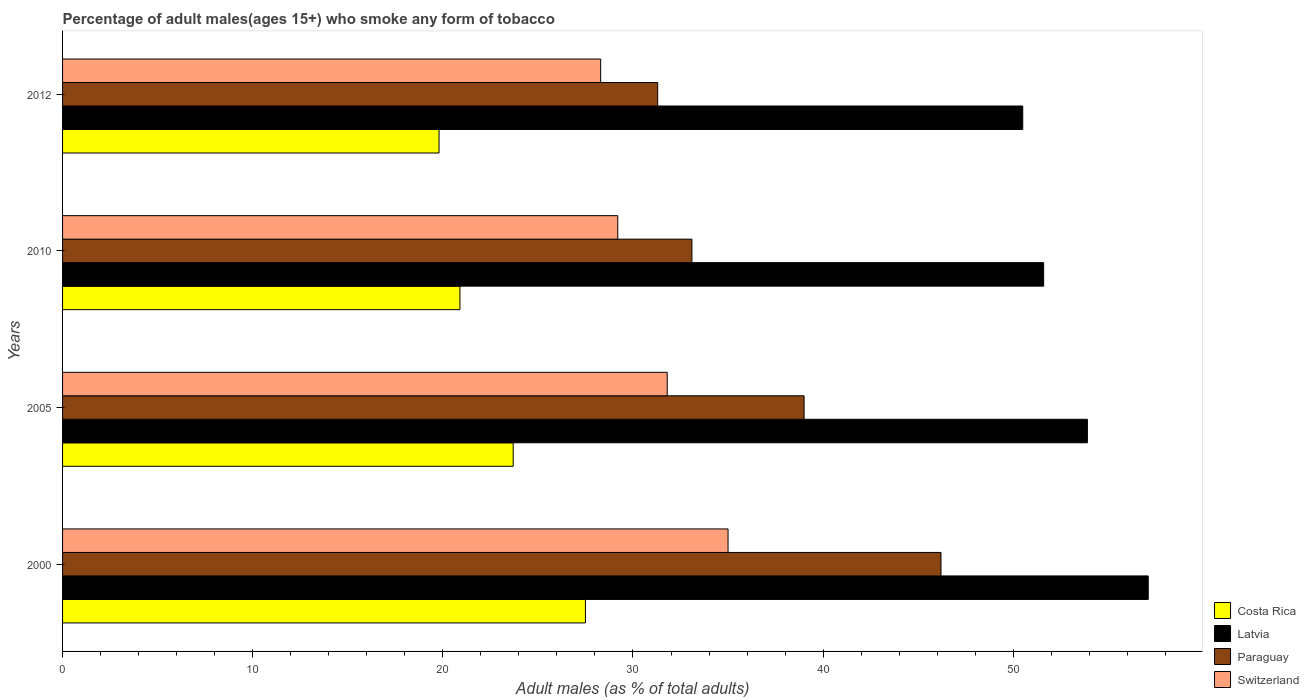Are the number of bars per tick equal to the number of legend labels?
Provide a short and direct response. Yes. How many bars are there on the 2nd tick from the bottom?
Offer a very short reply. 4. What is the percentage of adult males who smoke in Costa Rica in 2005?
Ensure brevity in your answer.  23.7. Across all years, what is the maximum percentage of adult males who smoke in Latvia?
Offer a terse response. 57.1. Across all years, what is the minimum percentage of adult males who smoke in Switzerland?
Offer a very short reply. 28.3. In which year was the percentage of adult males who smoke in Latvia minimum?
Offer a very short reply. 2012. What is the total percentage of adult males who smoke in Switzerland in the graph?
Keep it short and to the point. 124.3. What is the difference between the percentage of adult males who smoke in Switzerland in 2000 and that in 2012?
Offer a very short reply. 6.7. What is the average percentage of adult males who smoke in Costa Rica per year?
Your answer should be very brief. 22.97. In the year 2005, what is the difference between the percentage of adult males who smoke in Switzerland and percentage of adult males who smoke in Latvia?
Offer a terse response. -22.1. In how many years, is the percentage of adult males who smoke in Paraguay greater than 48 %?
Keep it short and to the point. 0. What is the ratio of the percentage of adult males who smoke in Latvia in 2000 to that in 2012?
Make the answer very short. 1.13. Is the difference between the percentage of adult males who smoke in Switzerland in 2000 and 2012 greater than the difference between the percentage of adult males who smoke in Latvia in 2000 and 2012?
Your answer should be compact. Yes. What is the difference between the highest and the second highest percentage of adult males who smoke in Paraguay?
Keep it short and to the point. 7.2. What is the difference between the highest and the lowest percentage of adult males who smoke in Switzerland?
Keep it short and to the point. 6.7. Is the sum of the percentage of adult males who smoke in Switzerland in 2010 and 2012 greater than the maximum percentage of adult males who smoke in Latvia across all years?
Offer a very short reply. Yes. Is it the case that in every year, the sum of the percentage of adult males who smoke in Costa Rica and percentage of adult males who smoke in Switzerland is greater than the sum of percentage of adult males who smoke in Paraguay and percentage of adult males who smoke in Latvia?
Provide a short and direct response. No. What does the 2nd bar from the bottom in 2000 represents?
Your answer should be compact. Latvia. Is it the case that in every year, the sum of the percentage of adult males who smoke in Switzerland and percentage of adult males who smoke in Costa Rica is greater than the percentage of adult males who smoke in Latvia?
Make the answer very short. No. How many bars are there?
Offer a very short reply. 16. Are all the bars in the graph horizontal?
Your answer should be compact. Yes. How many years are there in the graph?
Give a very brief answer. 4. What is the difference between two consecutive major ticks on the X-axis?
Offer a terse response. 10. Are the values on the major ticks of X-axis written in scientific E-notation?
Your response must be concise. No. Does the graph contain any zero values?
Your response must be concise. No. Does the graph contain grids?
Offer a very short reply. No. Where does the legend appear in the graph?
Keep it short and to the point. Bottom right. How many legend labels are there?
Provide a succinct answer. 4. What is the title of the graph?
Give a very brief answer. Percentage of adult males(ages 15+) who smoke any form of tobacco. What is the label or title of the X-axis?
Keep it short and to the point. Adult males (as % of total adults). What is the label or title of the Y-axis?
Give a very brief answer. Years. What is the Adult males (as % of total adults) in Costa Rica in 2000?
Your answer should be compact. 27.5. What is the Adult males (as % of total adults) of Latvia in 2000?
Provide a short and direct response. 57.1. What is the Adult males (as % of total adults) in Paraguay in 2000?
Your response must be concise. 46.2. What is the Adult males (as % of total adults) of Costa Rica in 2005?
Your response must be concise. 23.7. What is the Adult males (as % of total adults) of Latvia in 2005?
Give a very brief answer. 53.9. What is the Adult males (as % of total adults) in Switzerland in 2005?
Your answer should be very brief. 31.8. What is the Adult males (as % of total adults) in Costa Rica in 2010?
Keep it short and to the point. 20.9. What is the Adult males (as % of total adults) of Latvia in 2010?
Offer a terse response. 51.6. What is the Adult males (as % of total adults) of Paraguay in 2010?
Provide a succinct answer. 33.1. What is the Adult males (as % of total adults) of Switzerland in 2010?
Make the answer very short. 29.2. What is the Adult males (as % of total adults) of Costa Rica in 2012?
Ensure brevity in your answer.  19.8. What is the Adult males (as % of total adults) of Latvia in 2012?
Make the answer very short. 50.5. What is the Adult males (as % of total adults) of Paraguay in 2012?
Give a very brief answer. 31.3. What is the Adult males (as % of total adults) in Switzerland in 2012?
Your response must be concise. 28.3. Across all years, what is the maximum Adult males (as % of total adults) of Latvia?
Make the answer very short. 57.1. Across all years, what is the maximum Adult males (as % of total adults) in Paraguay?
Provide a short and direct response. 46.2. Across all years, what is the minimum Adult males (as % of total adults) of Costa Rica?
Make the answer very short. 19.8. Across all years, what is the minimum Adult males (as % of total adults) of Latvia?
Your answer should be compact. 50.5. Across all years, what is the minimum Adult males (as % of total adults) in Paraguay?
Ensure brevity in your answer.  31.3. Across all years, what is the minimum Adult males (as % of total adults) in Switzerland?
Your response must be concise. 28.3. What is the total Adult males (as % of total adults) of Costa Rica in the graph?
Your answer should be very brief. 91.9. What is the total Adult males (as % of total adults) in Latvia in the graph?
Provide a succinct answer. 213.1. What is the total Adult males (as % of total adults) of Paraguay in the graph?
Ensure brevity in your answer.  149.6. What is the total Adult males (as % of total adults) in Switzerland in the graph?
Your response must be concise. 124.3. What is the difference between the Adult males (as % of total adults) in Latvia in 2000 and that in 2005?
Your answer should be very brief. 3.2. What is the difference between the Adult males (as % of total adults) of Paraguay in 2000 and that in 2010?
Your answer should be very brief. 13.1. What is the difference between the Adult males (as % of total adults) in Switzerland in 2000 and that in 2010?
Your answer should be very brief. 5.8. What is the difference between the Adult males (as % of total adults) in Latvia in 2005 and that in 2010?
Your response must be concise. 2.3. What is the difference between the Adult males (as % of total adults) in Paraguay in 2005 and that in 2010?
Your response must be concise. 5.9. What is the difference between the Adult males (as % of total adults) of Latvia in 2005 and that in 2012?
Ensure brevity in your answer.  3.4. What is the difference between the Adult males (as % of total adults) in Paraguay in 2005 and that in 2012?
Ensure brevity in your answer.  7.7. What is the difference between the Adult males (as % of total adults) of Switzerland in 2005 and that in 2012?
Provide a succinct answer. 3.5. What is the difference between the Adult males (as % of total adults) of Latvia in 2010 and that in 2012?
Keep it short and to the point. 1.1. What is the difference between the Adult males (as % of total adults) of Paraguay in 2010 and that in 2012?
Make the answer very short. 1.8. What is the difference between the Adult males (as % of total adults) of Switzerland in 2010 and that in 2012?
Your response must be concise. 0.9. What is the difference between the Adult males (as % of total adults) of Costa Rica in 2000 and the Adult males (as % of total adults) of Latvia in 2005?
Keep it short and to the point. -26.4. What is the difference between the Adult males (as % of total adults) of Costa Rica in 2000 and the Adult males (as % of total adults) of Paraguay in 2005?
Make the answer very short. -11.5. What is the difference between the Adult males (as % of total adults) of Latvia in 2000 and the Adult males (as % of total adults) of Switzerland in 2005?
Make the answer very short. 25.3. What is the difference between the Adult males (as % of total adults) of Costa Rica in 2000 and the Adult males (as % of total adults) of Latvia in 2010?
Ensure brevity in your answer.  -24.1. What is the difference between the Adult males (as % of total adults) of Costa Rica in 2000 and the Adult males (as % of total adults) of Switzerland in 2010?
Give a very brief answer. -1.7. What is the difference between the Adult males (as % of total adults) in Latvia in 2000 and the Adult males (as % of total adults) in Switzerland in 2010?
Your answer should be very brief. 27.9. What is the difference between the Adult males (as % of total adults) of Costa Rica in 2000 and the Adult males (as % of total adults) of Paraguay in 2012?
Offer a terse response. -3.8. What is the difference between the Adult males (as % of total adults) of Costa Rica in 2000 and the Adult males (as % of total adults) of Switzerland in 2012?
Your answer should be very brief. -0.8. What is the difference between the Adult males (as % of total adults) of Latvia in 2000 and the Adult males (as % of total adults) of Paraguay in 2012?
Offer a terse response. 25.8. What is the difference between the Adult males (as % of total adults) of Latvia in 2000 and the Adult males (as % of total adults) of Switzerland in 2012?
Provide a short and direct response. 28.8. What is the difference between the Adult males (as % of total adults) of Costa Rica in 2005 and the Adult males (as % of total adults) of Latvia in 2010?
Your answer should be very brief. -27.9. What is the difference between the Adult males (as % of total adults) of Costa Rica in 2005 and the Adult males (as % of total adults) of Paraguay in 2010?
Ensure brevity in your answer.  -9.4. What is the difference between the Adult males (as % of total adults) of Costa Rica in 2005 and the Adult males (as % of total adults) of Switzerland in 2010?
Offer a very short reply. -5.5. What is the difference between the Adult males (as % of total adults) in Latvia in 2005 and the Adult males (as % of total adults) in Paraguay in 2010?
Your answer should be very brief. 20.8. What is the difference between the Adult males (as % of total adults) of Latvia in 2005 and the Adult males (as % of total adults) of Switzerland in 2010?
Offer a very short reply. 24.7. What is the difference between the Adult males (as % of total adults) of Paraguay in 2005 and the Adult males (as % of total adults) of Switzerland in 2010?
Provide a succinct answer. 9.8. What is the difference between the Adult males (as % of total adults) of Costa Rica in 2005 and the Adult males (as % of total adults) of Latvia in 2012?
Keep it short and to the point. -26.8. What is the difference between the Adult males (as % of total adults) in Costa Rica in 2005 and the Adult males (as % of total adults) in Switzerland in 2012?
Provide a succinct answer. -4.6. What is the difference between the Adult males (as % of total adults) of Latvia in 2005 and the Adult males (as % of total adults) of Paraguay in 2012?
Offer a very short reply. 22.6. What is the difference between the Adult males (as % of total adults) of Latvia in 2005 and the Adult males (as % of total adults) of Switzerland in 2012?
Provide a short and direct response. 25.6. What is the difference between the Adult males (as % of total adults) of Paraguay in 2005 and the Adult males (as % of total adults) of Switzerland in 2012?
Your answer should be compact. 10.7. What is the difference between the Adult males (as % of total adults) in Costa Rica in 2010 and the Adult males (as % of total adults) in Latvia in 2012?
Provide a short and direct response. -29.6. What is the difference between the Adult males (as % of total adults) of Costa Rica in 2010 and the Adult males (as % of total adults) of Paraguay in 2012?
Your answer should be very brief. -10.4. What is the difference between the Adult males (as % of total adults) in Costa Rica in 2010 and the Adult males (as % of total adults) in Switzerland in 2012?
Offer a terse response. -7.4. What is the difference between the Adult males (as % of total adults) in Latvia in 2010 and the Adult males (as % of total adults) in Paraguay in 2012?
Offer a very short reply. 20.3. What is the difference between the Adult males (as % of total adults) of Latvia in 2010 and the Adult males (as % of total adults) of Switzerland in 2012?
Keep it short and to the point. 23.3. What is the average Adult males (as % of total adults) in Costa Rica per year?
Your answer should be very brief. 22.98. What is the average Adult males (as % of total adults) of Latvia per year?
Give a very brief answer. 53.27. What is the average Adult males (as % of total adults) in Paraguay per year?
Ensure brevity in your answer.  37.4. What is the average Adult males (as % of total adults) in Switzerland per year?
Keep it short and to the point. 31.07. In the year 2000, what is the difference between the Adult males (as % of total adults) of Costa Rica and Adult males (as % of total adults) of Latvia?
Your answer should be very brief. -29.6. In the year 2000, what is the difference between the Adult males (as % of total adults) in Costa Rica and Adult males (as % of total adults) in Paraguay?
Make the answer very short. -18.7. In the year 2000, what is the difference between the Adult males (as % of total adults) in Costa Rica and Adult males (as % of total adults) in Switzerland?
Ensure brevity in your answer.  -7.5. In the year 2000, what is the difference between the Adult males (as % of total adults) in Latvia and Adult males (as % of total adults) in Paraguay?
Keep it short and to the point. 10.9. In the year 2000, what is the difference between the Adult males (as % of total adults) in Latvia and Adult males (as % of total adults) in Switzerland?
Ensure brevity in your answer.  22.1. In the year 2005, what is the difference between the Adult males (as % of total adults) of Costa Rica and Adult males (as % of total adults) of Latvia?
Offer a very short reply. -30.2. In the year 2005, what is the difference between the Adult males (as % of total adults) in Costa Rica and Adult males (as % of total adults) in Paraguay?
Ensure brevity in your answer.  -15.3. In the year 2005, what is the difference between the Adult males (as % of total adults) in Costa Rica and Adult males (as % of total adults) in Switzerland?
Ensure brevity in your answer.  -8.1. In the year 2005, what is the difference between the Adult males (as % of total adults) of Latvia and Adult males (as % of total adults) of Paraguay?
Keep it short and to the point. 14.9. In the year 2005, what is the difference between the Adult males (as % of total adults) of Latvia and Adult males (as % of total adults) of Switzerland?
Ensure brevity in your answer.  22.1. In the year 2005, what is the difference between the Adult males (as % of total adults) of Paraguay and Adult males (as % of total adults) of Switzerland?
Your answer should be very brief. 7.2. In the year 2010, what is the difference between the Adult males (as % of total adults) in Costa Rica and Adult males (as % of total adults) in Latvia?
Provide a succinct answer. -30.7. In the year 2010, what is the difference between the Adult males (as % of total adults) in Costa Rica and Adult males (as % of total adults) in Paraguay?
Your answer should be very brief. -12.2. In the year 2010, what is the difference between the Adult males (as % of total adults) in Latvia and Adult males (as % of total adults) in Switzerland?
Provide a short and direct response. 22.4. In the year 2010, what is the difference between the Adult males (as % of total adults) in Paraguay and Adult males (as % of total adults) in Switzerland?
Provide a succinct answer. 3.9. In the year 2012, what is the difference between the Adult males (as % of total adults) in Costa Rica and Adult males (as % of total adults) in Latvia?
Give a very brief answer. -30.7. In the year 2012, what is the difference between the Adult males (as % of total adults) of Latvia and Adult males (as % of total adults) of Paraguay?
Ensure brevity in your answer.  19.2. In the year 2012, what is the difference between the Adult males (as % of total adults) in Latvia and Adult males (as % of total adults) in Switzerland?
Your response must be concise. 22.2. In the year 2012, what is the difference between the Adult males (as % of total adults) of Paraguay and Adult males (as % of total adults) of Switzerland?
Make the answer very short. 3. What is the ratio of the Adult males (as % of total adults) in Costa Rica in 2000 to that in 2005?
Your response must be concise. 1.16. What is the ratio of the Adult males (as % of total adults) of Latvia in 2000 to that in 2005?
Offer a terse response. 1.06. What is the ratio of the Adult males (as % of total adults) of Paraguay in 2000 to that in 2005?
Offer a terse response. 1.18. What is the ratio of the Adult males (as % of total adults) in Switzerland in 2000 to that in 2005?
Ensure brevity in your answer.  1.1. What is the ratio of the Adult males (as % of total adults) of Costa Rica in 2000 to that in 2010?
Ensure brevity in your answer.  1.32. What is the ratio of the Adult males (as % of total adults) of Latvia in 2000 to that in 2010?
Offer a very short reply. 1.11. What is the ratio of the Adult males (as % of total adults) of Paraguay in 2000 to that in 2010?
Keep it short and to the point. 1.4. What is the ratio of the Adult males (as % of total adults) in Switzerland in 2000 to that in 2010?
Keep it short and to the point. 1.2. What is the ratio of the Adult males (as % of total adults) in Costa Rica in 2000 to that in 2012?
Ensure brevity in your answer.  1.39. What is the ratio of the Adult males (as % of total adults) of Latvia in 2000 to that in 2012?
Offer a terse response. 1.13. What is the ratio of the Adult males (as % of total adults) in Paraguay in 2000 to that in 2012?
Give a very brief answer. 1.48. What is the ratio of the Adult males (as % of total adults) in Switzerland in 2000 to that in 2012?
Provide a succinct answer. 1.24. What is the ratio of the Adult males (as % of total adults) of Costa Rica in 2005 to that in 2010?
Give a very brief answer. 1.13. What is the ratio of the Adult males (as % of total adults) of Latvia in 2005 to that in 2010?
Provide a short and direct response. 1.04. What is the ratio of the Adult males (as % of total adults) in Paraguay in 2005 to that in 2010?
Offer a very short reply. 1.18. What is the ratio of the Adult males (as % of total adults) of Switzerland in 2005 to that in 2010?
Make the answer very short. 1.09. What is the ratio of the Adult males (as % of total adults) in Costa Rica in 2005 to that in 2012?
Provide a short and direct response. 1.2. What is the ratio of the Adult males (as % of total adults) of Latvia in 2005 to that in 2012?
Make the answer very short. 1.07. What is the ratio of the Adult males (as % of total adults) in Paraguay in 2005 to that in 2012?
Provide a short and direct response. 1.25. What is the ratio of the Adult males (as % of total adults) of Switzerland in 2005 to that in 2012?
Your answer should be very brief. 1.12. What is the ratio of the Adult males (as % of total adults) of Costa Rica in 2010 to that in 2012?
Provide a succinct answer. 1.06. What is the ratio of the Adult males (as % of total adults) of Latvia in 2010 to that in 2012?
Offer a very short reply. 1.02. What is the ratio of the Adult males (as % of total adults) of Paraguay in 2010 to that in 2012?
Give a very brief answer. 1.06. What is the ratio of the Adult males (as % of total adults) in Switzerland in 2010 to that in 2012?
Make the answer very short. 1.03. What is the difference between the highest and the second highest Adult males (as % of total adults) of Latvia?
Offer a very short reply. 3.2. What is the difference between the highest and the second highest Adult males (as % of total adults) of Switzerland?
Provide a succinct answer. 3.2. What is the difference between the highest and the lowest Adult males (as % of total adults) in Switzerland?
Give a very brief answer. 6.7. 